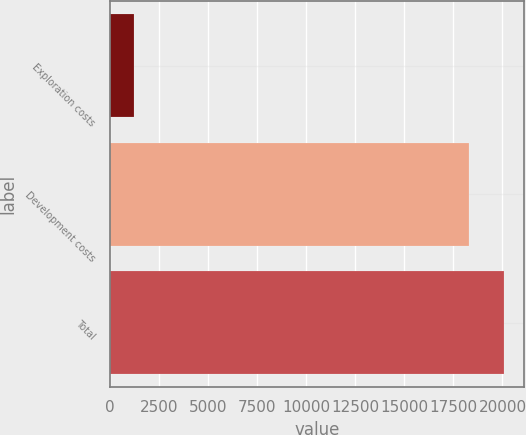Convert chart. <chart><loc_0><loc_0><loc_500><loc_500><bar_chart><fcel>Exploration costs<fcel>Development costs<fcel>Total<nl><fcel>1222<fcel>18274<fcel>20102<nl></chart> 